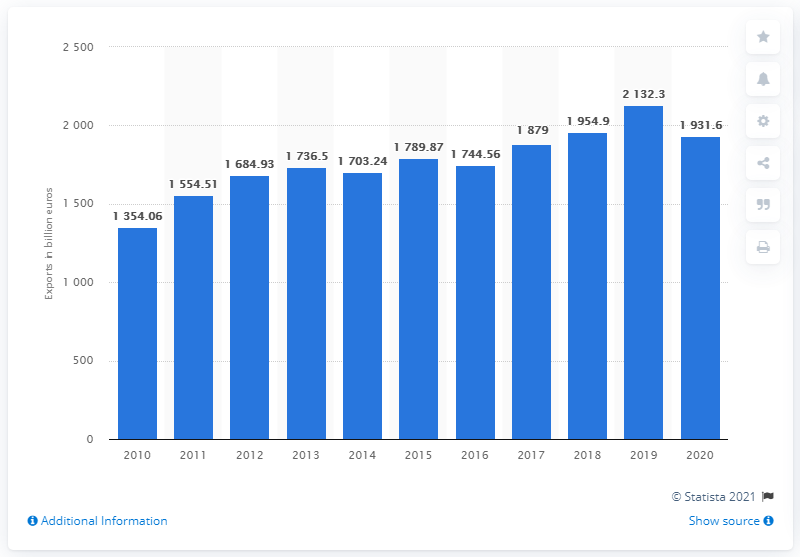Specify some key components in this picture. In 2020, the value of goods exported from the EU was 19,316. 